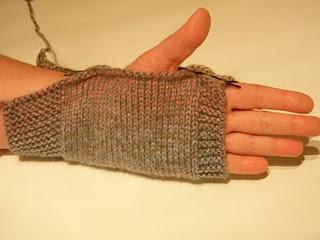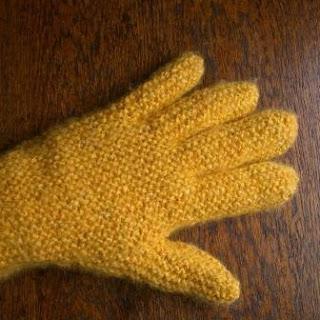The first image is the image on the left, the second image is the image on the right. Given the left and right images, does the statement "The left and right image contains a total of three gloves." hold true? Answer yes or no. No. The first image is the image on the left, the second image is the image on the right. For the images displayed, is the sentence "One image shows a completed pair of 'mittens', and the other image shows a single completed item worn on the hand." factually correct? Answer yes or no. No. 